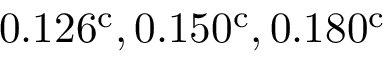Convert formula to latex. <formula><loc_0><loc_0><loc_500><loc_500>0 . 1 2 6 ^ { c } , 0 . 1 5 0 ^ { c } , 0 . 1 8 0 ^ { c }</formula> 